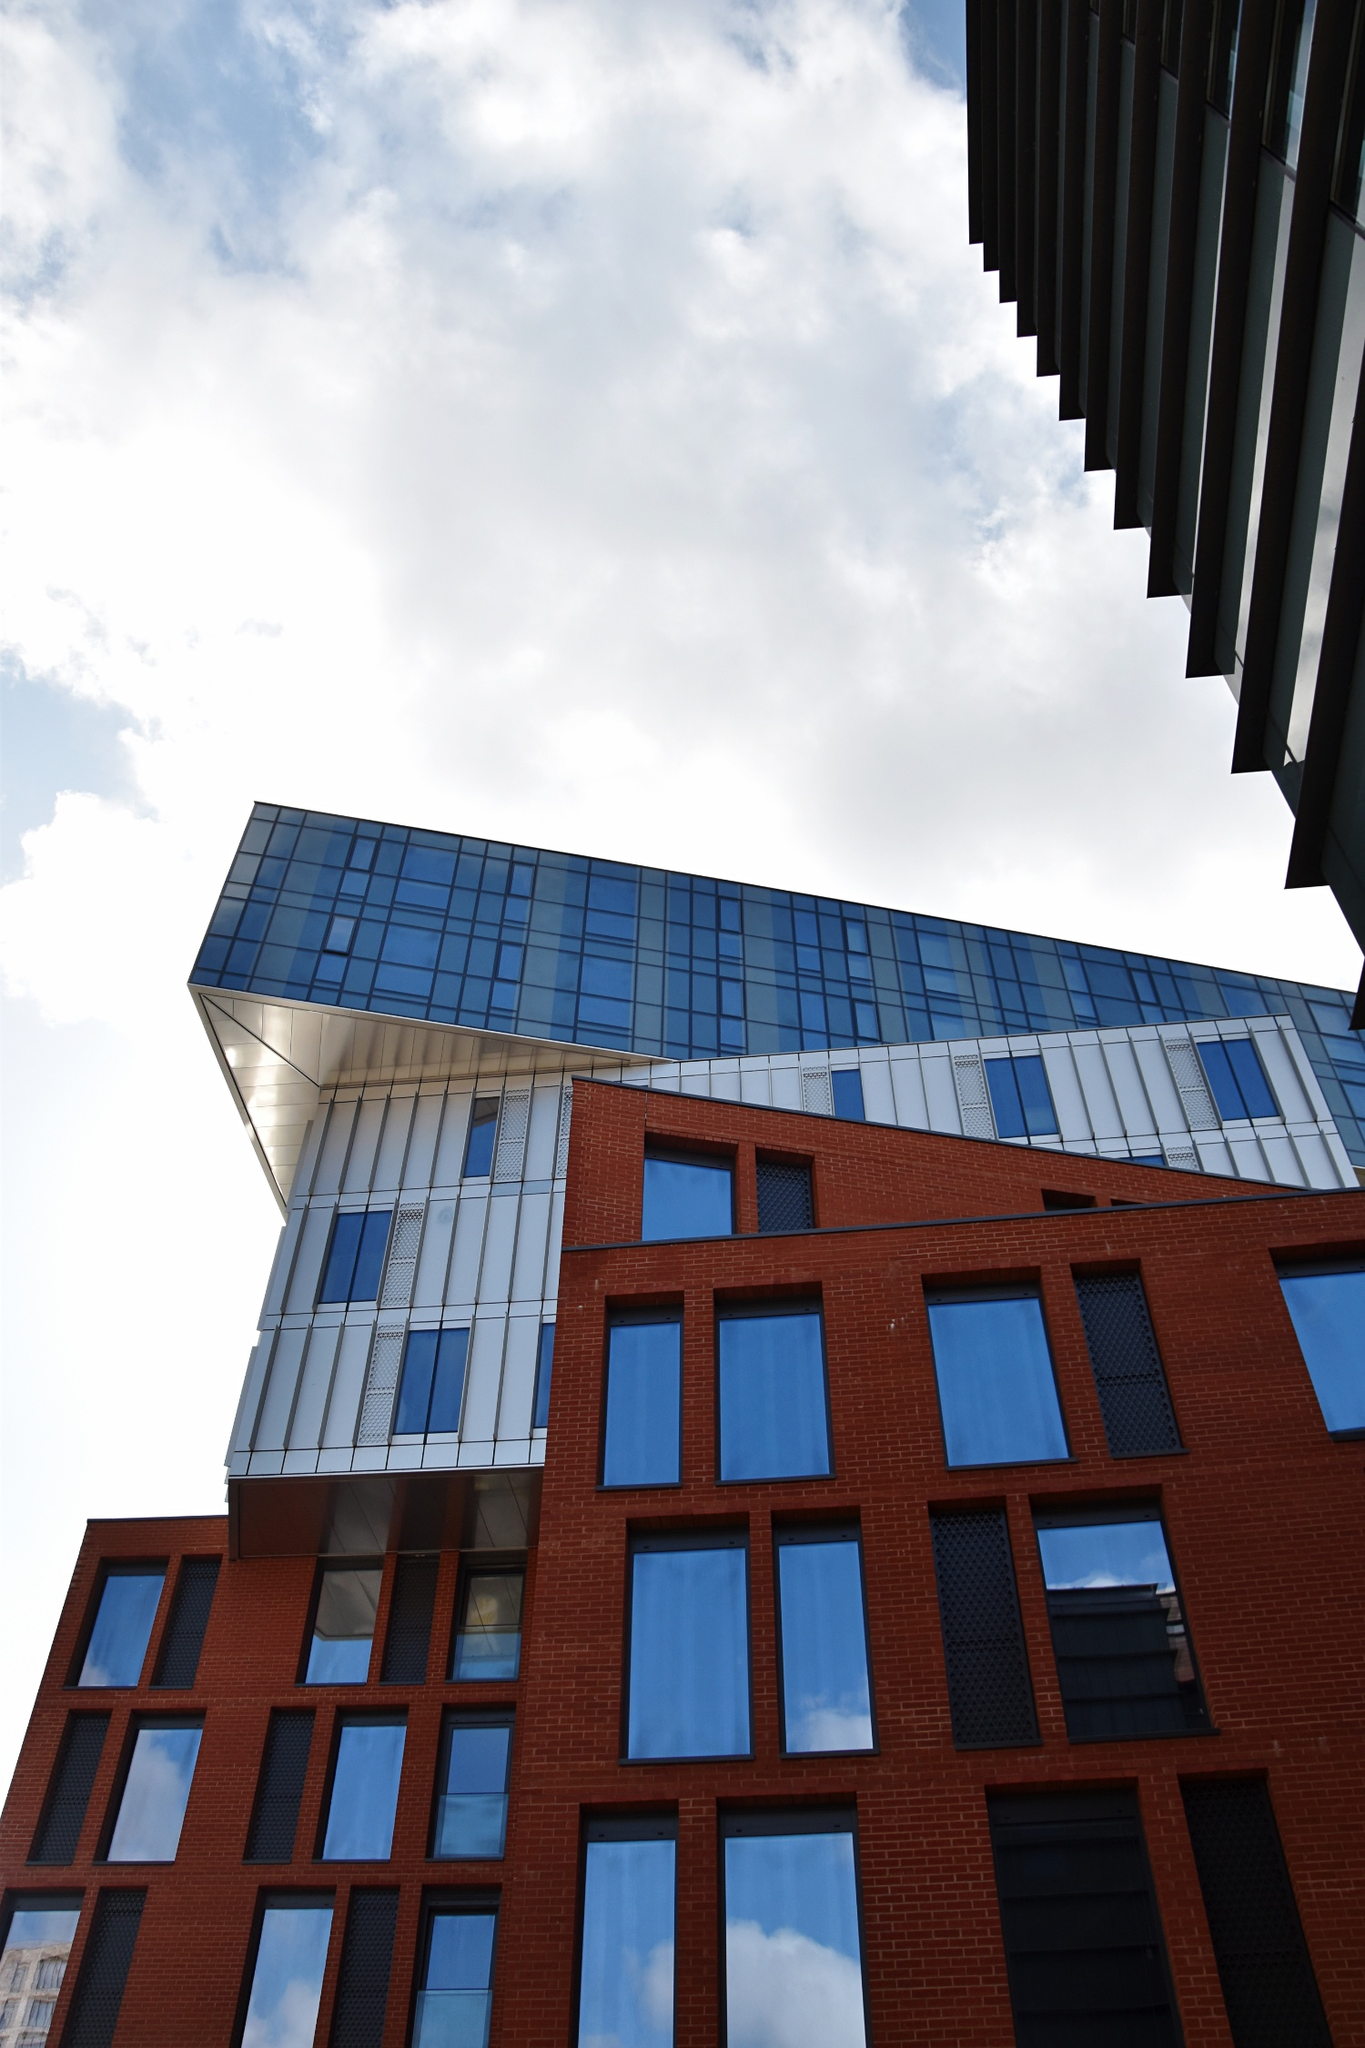Can you tell me a fantastical story involving this building? Once upon a time, in the bustling heart of a modern metropolis, there stood a remarkable building unlike any other. This architectural marvel, with its red brick base and towering glass peak, was not just a structure but a sentinel of dreams. Legend had it that the building was enchanted; every night, as the city slept, it would come to life.

As the clock struck midnight, the building’s windows would begin to shimmer with a soft, ethereal light. The red bricks would warm and glow, as if filled with the whispers of a thousand stories. The glass tower, now a beacon of untold tales, would cast images of fantastical creatures and distant lands across the sky.

Passersby who glimpsed these nightly spectacles believed that the building was a portal to another realm. They spoke of seeing dragons soaring through the clouds, mermaids dancing in waves of light, and ancient forests brimming with magical creatures. Some even claimed that on particularly clear nights, one could see visions of the past and future, moments of joy and sorrow, triumphs and tragedies, all playing out on the glass surface like a grand, celestial theater.

At the heart of this enchantment was a secret known only to a select few: the building housed the Dreamweaver’s Workshop. The Dreamweaver, an ageless, mystical being, resided in the highest chamber of the glass tower. With a mere wave of their hand, they could weave dreams from the starlight, crafting visions that would inspire, comfort, and guide the souls of the city.

Each night, as the moon rose, the Dreamweaver would open the windows of the glass tower, allowing the visions to spill out and dance across the sky. These dreams would drift down to earth, entering the minds of those who slumbered, filling their sleep with wonder and delight.

And so, the building stood as a guardian of dreams, its walls filled with magic and its windows a canvas for the imagination. To this day, if you stand quietly near the building at midnight, you might just catch a glimpse of its nightly enchantment—a dragon’s wing, a mermaid’s tail, or a fleeting scene from a dream yet to come. 